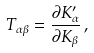Convert formula to latex. <formula><loc_0><loc_0><loc_500><loc_500>T _ { \alpha \beta } = \frac { \partial K ^ { \prime } _ { \alpha } } { \partial K _ { \beta } } \, ,</formula> 